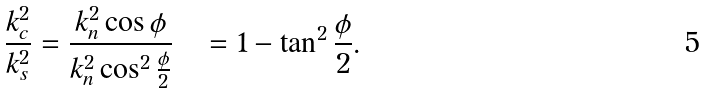Convert formula to latex. <formula><loc_0><loc_0><loc_500><loc_500>\frac { k _ { c } ^ { 2 } } { k _ { s } ^ { 2 } } & = \frac { k _ { n } ^ { 2 } \cos \phi } { k _ { n } ^ { 2 } \cos ^ { 2 } \frac { \phi } { 2 } } \quad = 1 - \tan ^ { 2 } \frac { \phi } { 2 } .</formula> 